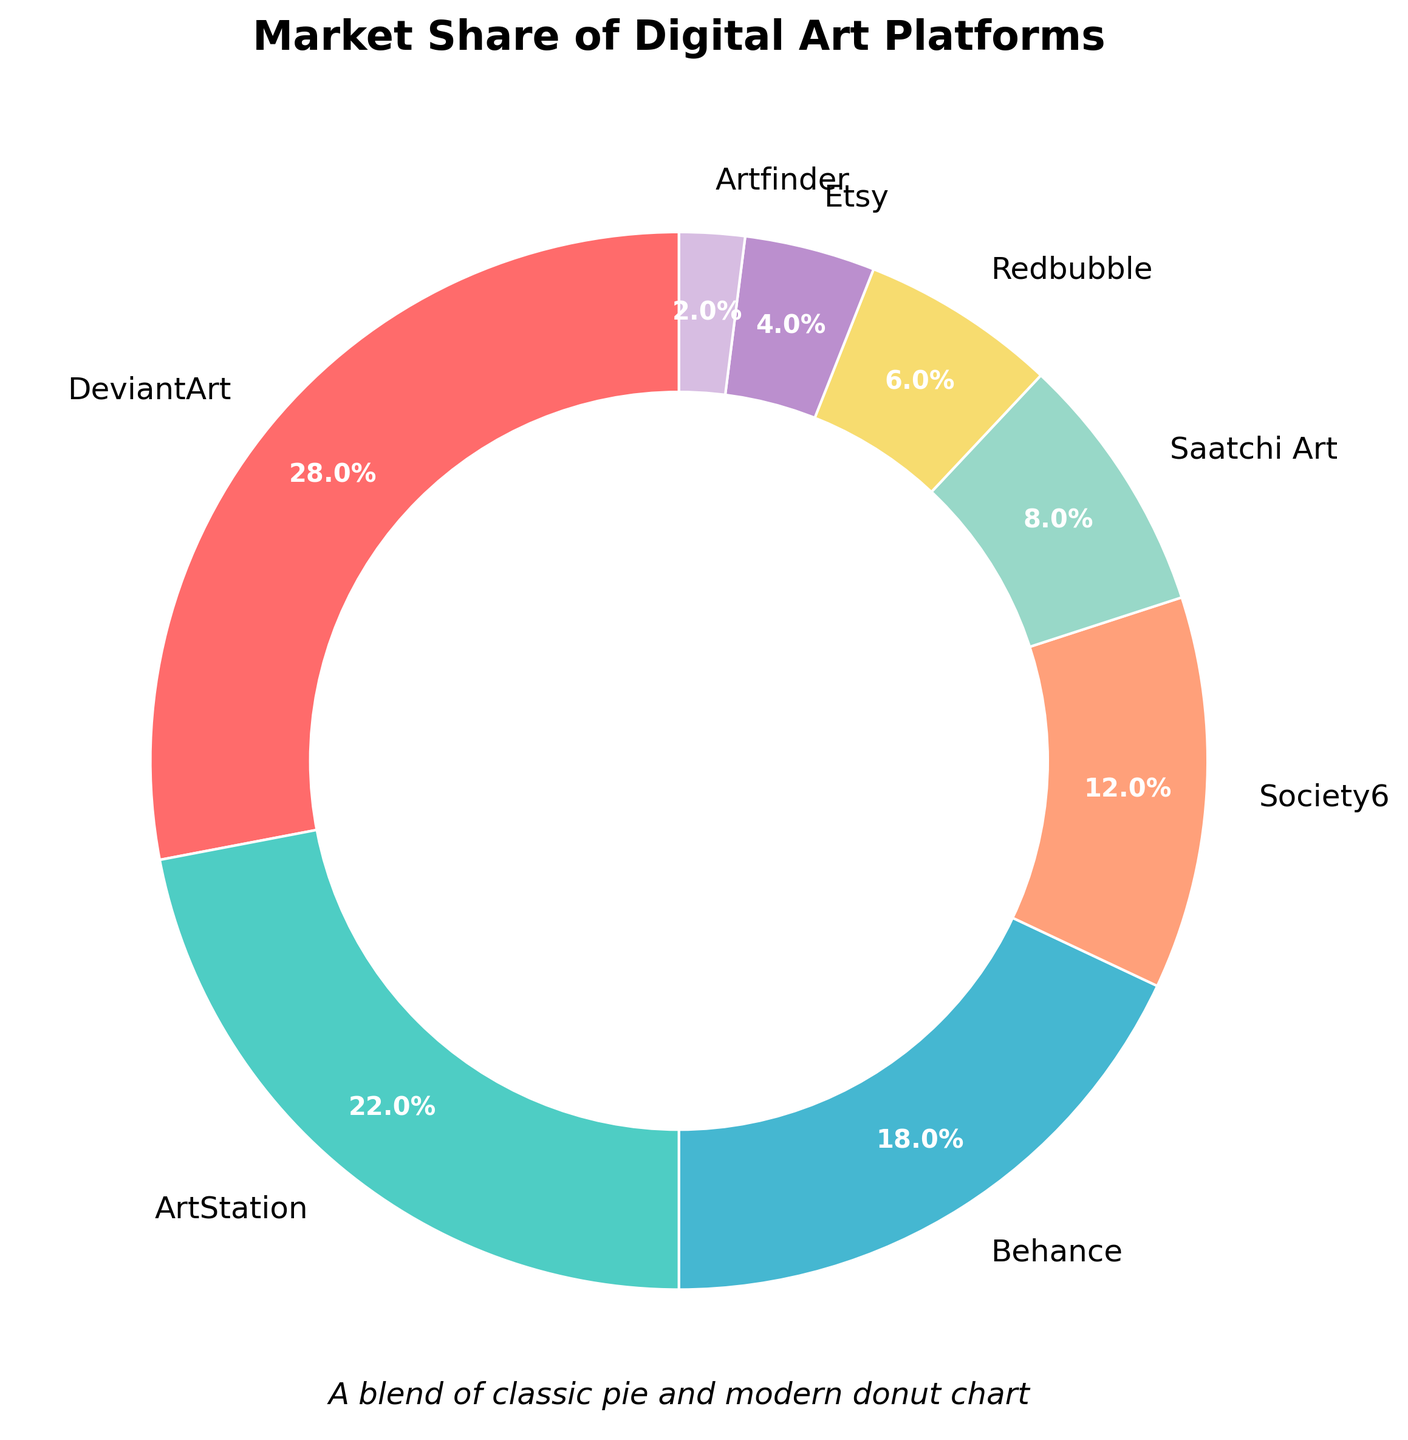Which platform has the highest market share? To determine which platform has the highest market share, look for the largest segment in the pie chart. The largest segment corresponds to DeviantArt.
Answer: DeviantArt What is the combined market share of Society6 and Saatchi Art? To find the combined market share of Society6 and Saatchi Art, add their individual market shares: 12 + 8 = 20.
Answer: 20 Which two platforms together make up more than 50% of the market share? To identify two platforms that together make up more than 50% of the market share, consider the largest segments. DeviantArt (28%) and ArtStation (22%) together account for 28 + 22 = 50, which is exactly 50%, not more. Next, include a smaller share platform: DeviantArt (28%) and Behance (18%) make 28 + 18 = 46, not more than 50. Finally, DeviantArt (28%), ArtStation (22%), and Behance (18%) add up to 68.
Answer: DeviantArt and ArtStation What is the average market share of the platforms? To calculate the average market share, sum the market shares of all platforms and divide by the number of platforms. The sum is 28 + 22 + 18 + 12 + 8 + 6 + 4 + 2 = 100. There are 8 platforms, so the average market share is 100 / 8 = 12.5.
Answer: 12.5 Which platform has a market share twice that of Redbubble? Find the market share of Redbubble (6%), then identify the platform with twice that share (6 * 2 = 12%). Society6 has a market share of 12%, which is twice that of Redbubble.
Answer: Society6 Identify the platform with the market share closest to the median value of the dataset. To find the median market share, list all market shares in ascending order: 2, 4, 6, 8, 12, 18, 22, 28. The median lies between the 4th and 5th values, which are 8 and 12, so the median is (8 + 12) / 2 = 10. The platform with the market share closest to 10 is Society6 with 12%.
Answer: Society6 How much larger is the market share of DeviantArt compared to Behance? To determine the difference in market share between DeviantArt and Behance, subtract Behance's market share from DeviantArt's: 28 - 18 = 10.
Answer: 10 What is the total market share of platforms with less than 10% market share each? Identify platforms with less than 10% market share (Saatchi Art, Redbubble, Etsy, Artfinder), then sum their shares: 8 + 6 + 4 + 2 = 20.
Answer: 20 Which segment is represented by the green color in the chart? Identify the green segment visually in the pie chart. The green color represents ArtStation.
Answer: ArtStation 